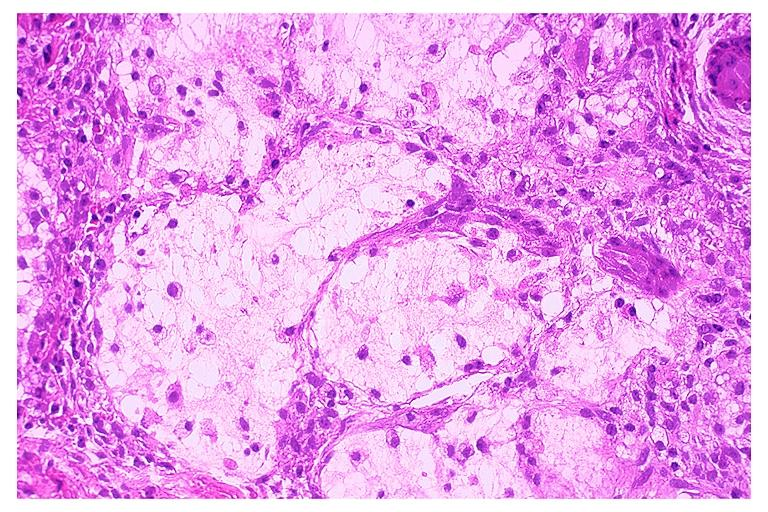s oral present?
Answer the question using a single word or phrase. Yes 